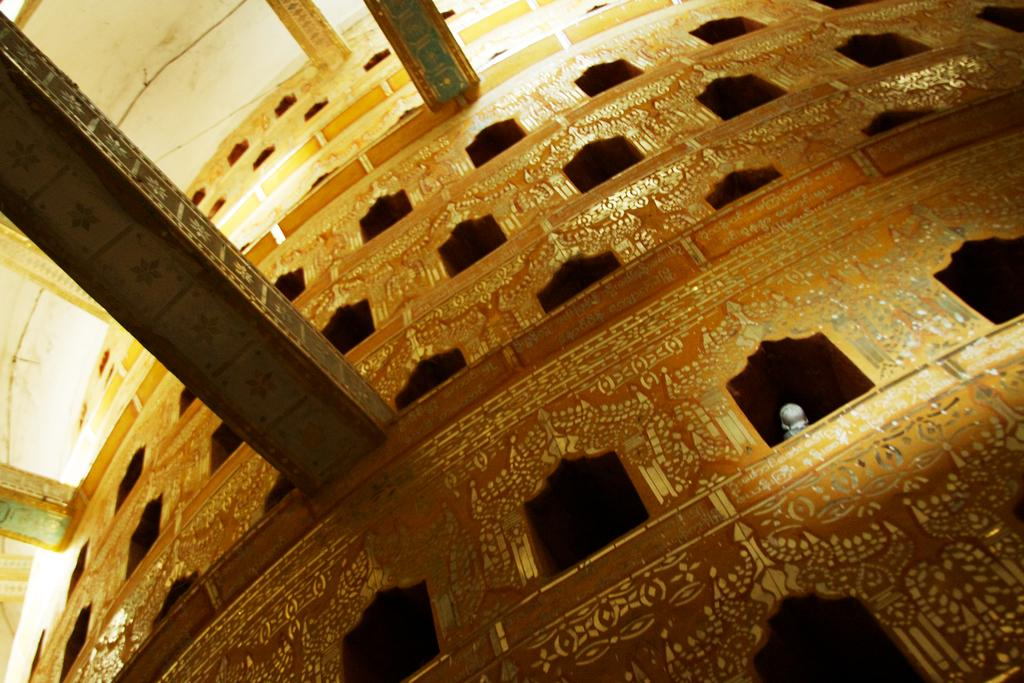What is the main structure in the center of the image? There is a building in the center of the image. What are some features of the building? The building has a wall, a roof, and pillars. Is there any decoration or design on the building? Yes, there is a design on the wall of the building. Can you see a girl playing with a whip in the image? No, there is no girl or whip present in the image. The image only features a building with a wall, roof, and pillars, along with a design on the wall. 